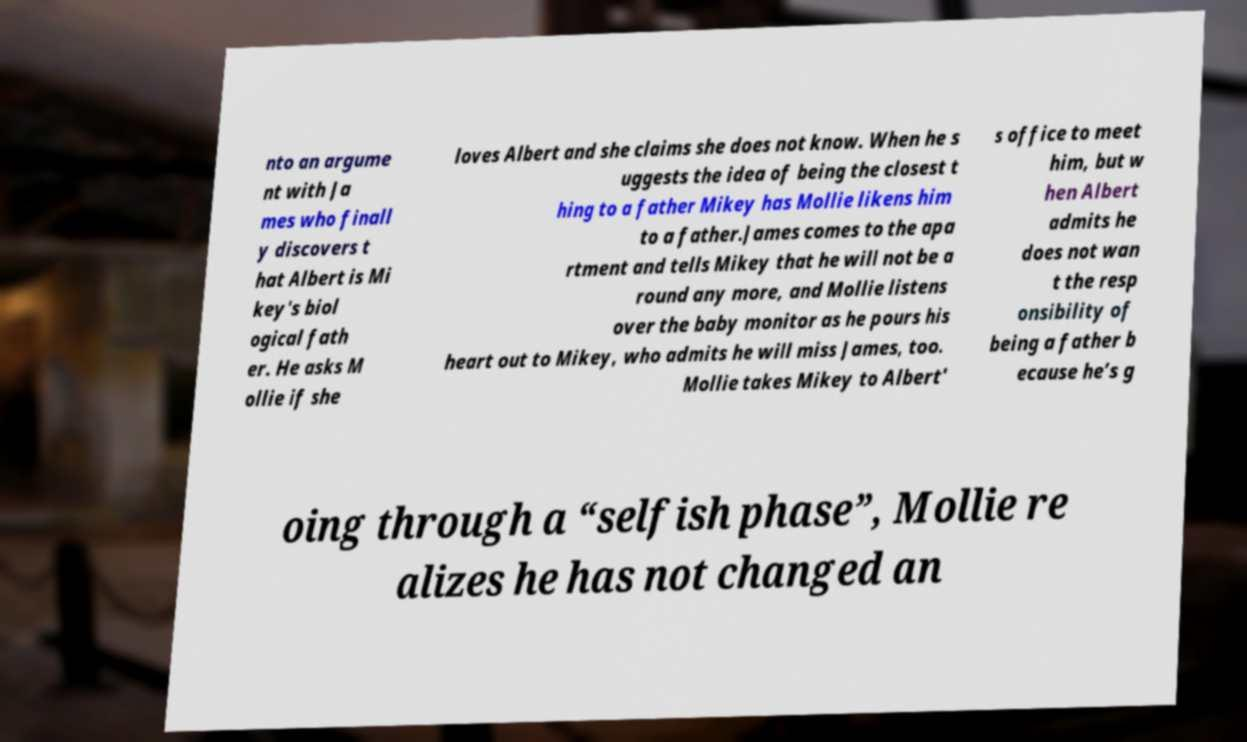What messages or text are displayed in this image? I need them in a readable, typed format. nto an argume nt with Ja mes who finall y discovers t hat Albert is Mi key's biol ogical fath er. He asks M ollie if she loves Albert and she claims she does not know. When he s uggests the idea of being the closest t hing to a father Mikey has Mollie likens him to a father.James comes to the apa rtment and tells Mikey that he will not be a round any more, and Mollie listens over the baby monitor as he pours his heart out to Mikey, who admits he will miss James, too. Mollie takes Mikey to Albert' s office to meet him, but w hen Albert admits he does not wan t the resp onsibility of being a father b ecause he’s g oing through a “selfish phase”, Mollie re alizes he has not changed an 